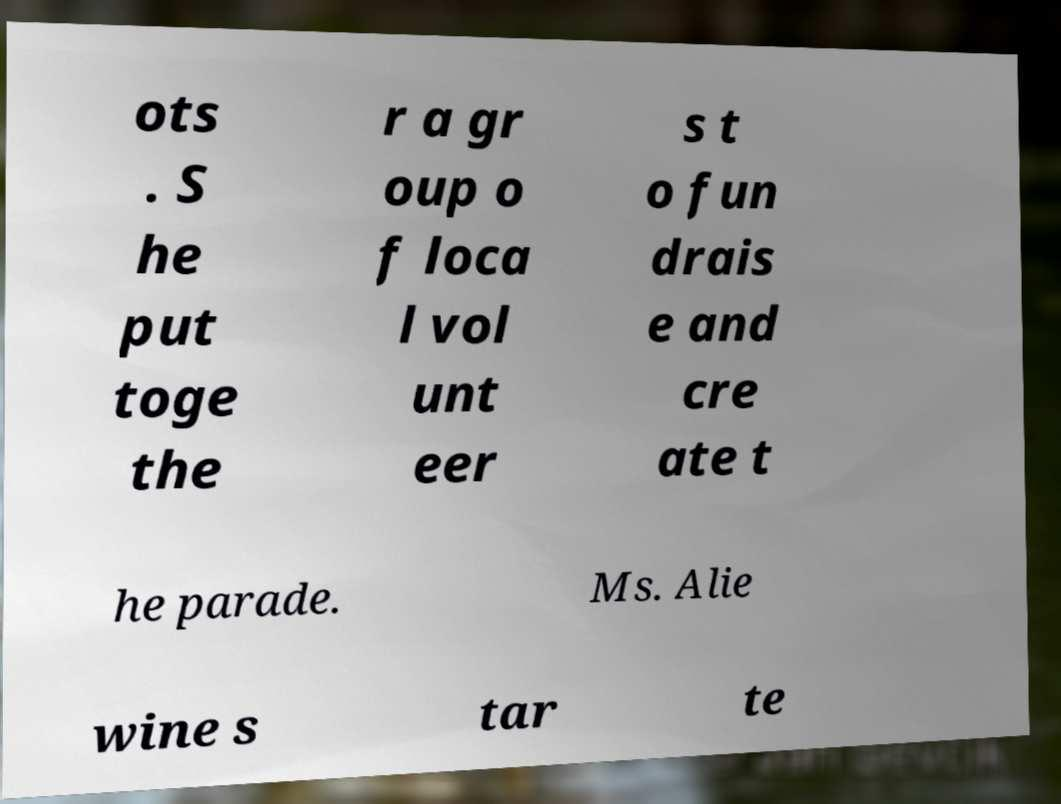Please read and relay the text visible in this image. What does it say? ots . S he put toge the r a gr oup o f loca l vol unt eer s t o fun drais e and cre ate t he parade. Ms. Alie wine s tar te 